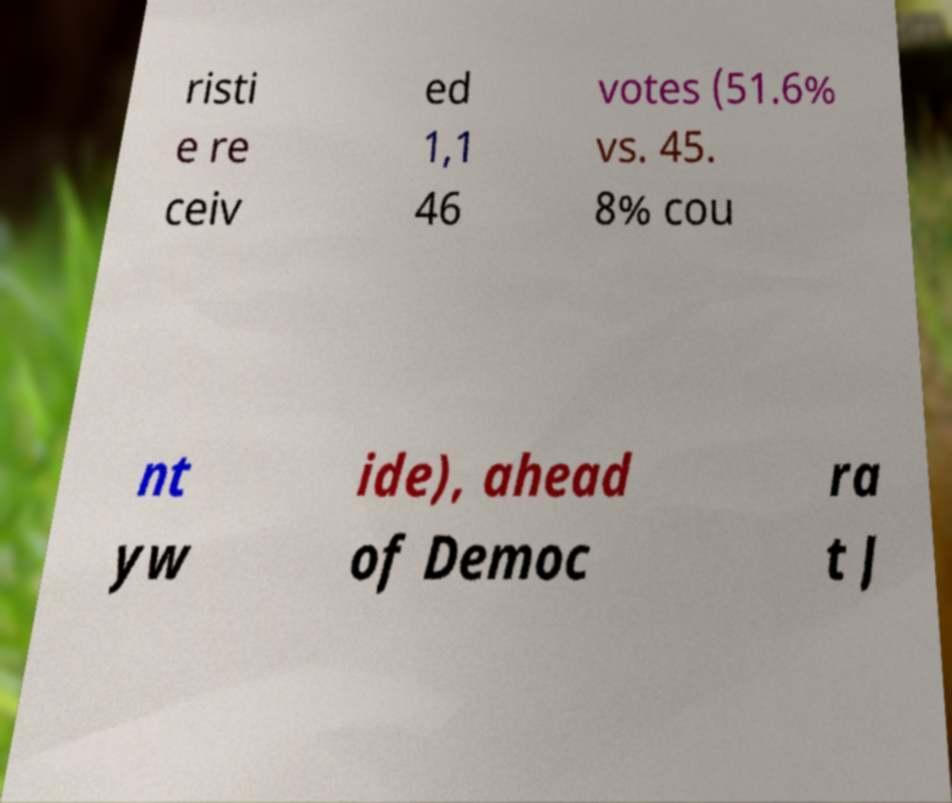Please read and relay the text visible in this image. What does it say? risti e re ceiv ed 1,1 46 votes (51.6% vs. 45. 8% cou nt yw ide), ahead of Democ ra t J 